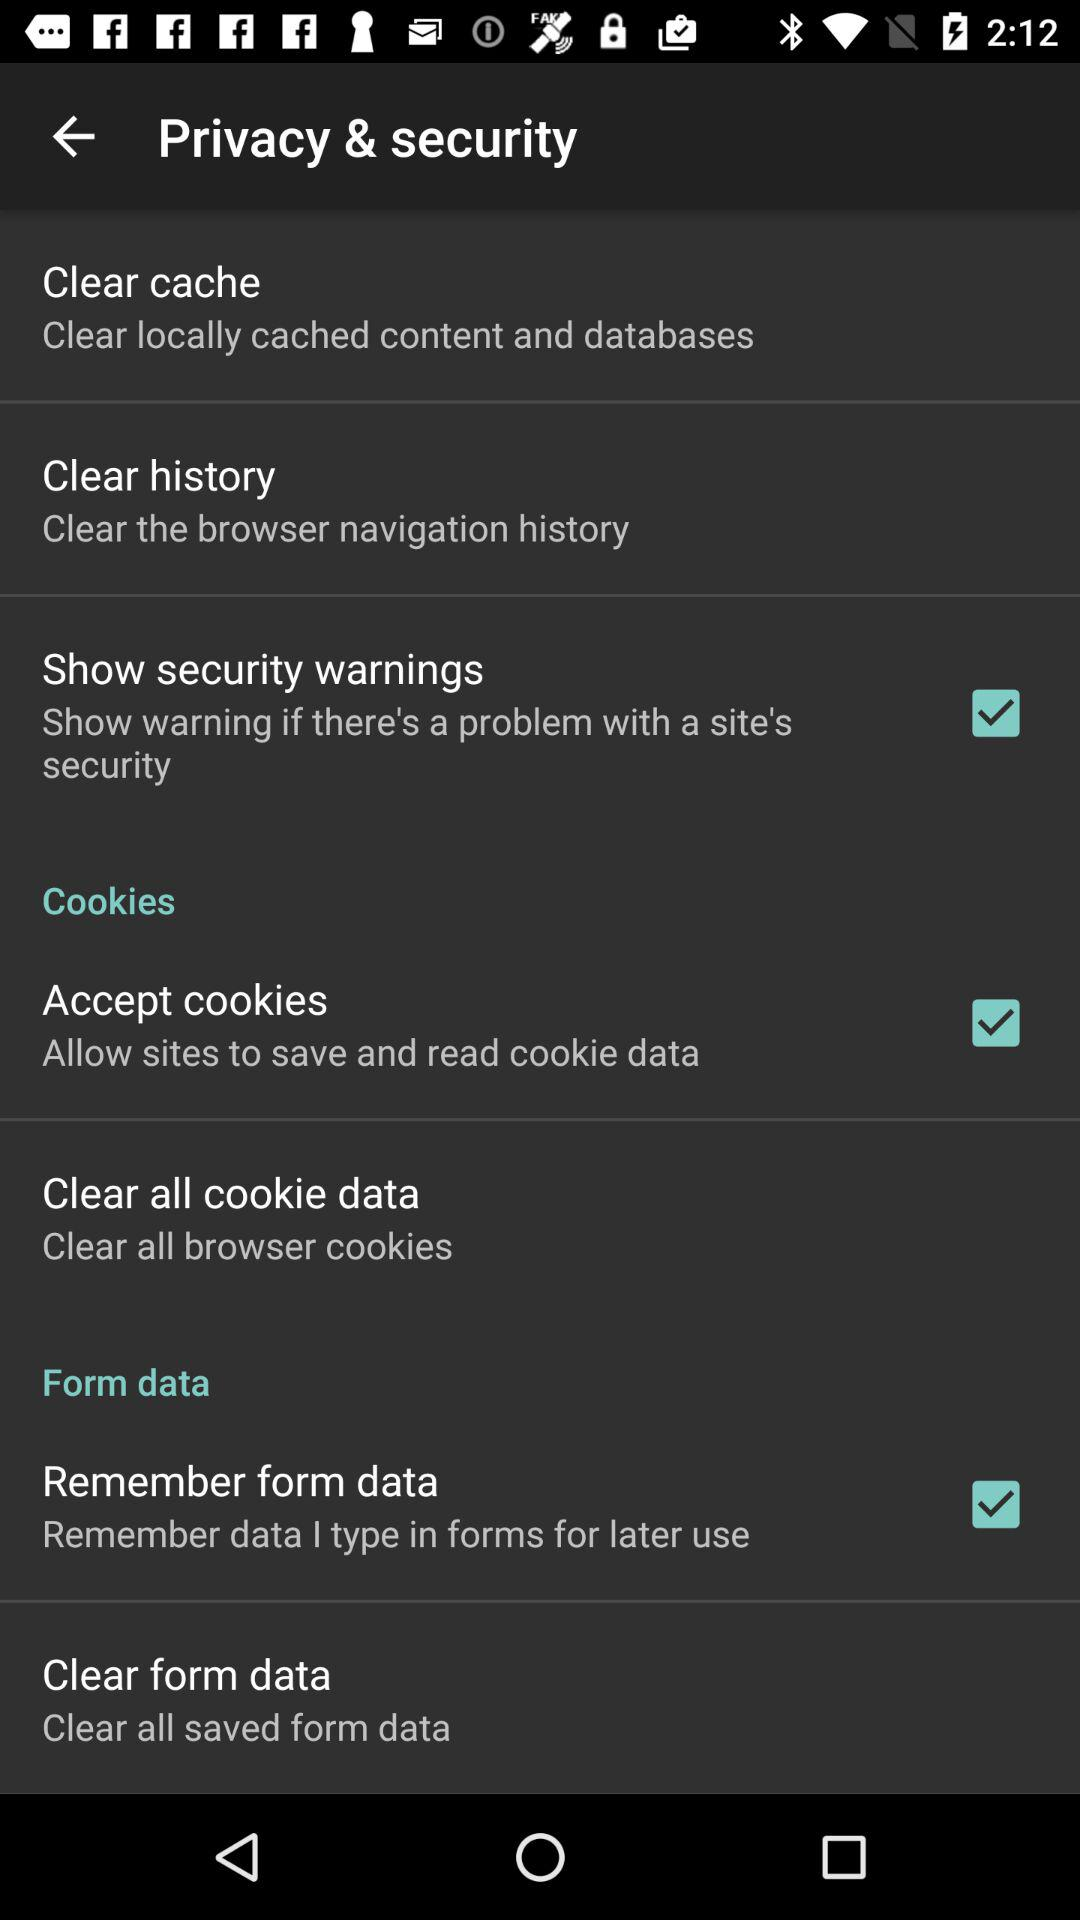How many items have checkboxes in the privacy and security settings?
Answer the question using a single word or phrase. 3 